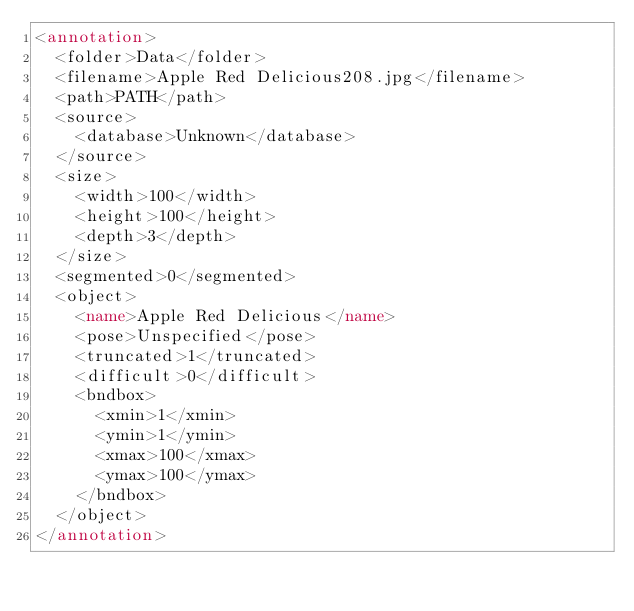Convert code to text. <code><loc_0><loc_0><loc_500><loc_500><_XML_><annotation>
	<folder>Data</folder>
	<filename>Apple Red Delicious208.jpg</filename>
	<path>PATH</path>
	<source>
		<database>Unknown</database>
	</source>
	<size>
		<width>100</width>
		<height>100</height>
		<depth>3</depth>
	</size>
	<segmented>0</segmented>
	<object>
		<name>Apple Red Delicious</name>
		<pose>Unspecified</pose>
		<truncated>1</truncated>
		<difficult>0</difficult>
		<bndbox>
			<xmin>1</xmin>
			<ymin>1</ymin>
			<xmax>100</xmax>
			<ymax>100</ymax>
		</bndbox>
	</object>
</annotation>
</code> 